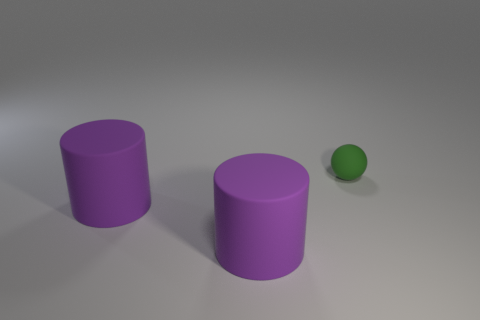How many things are matte objects that are on the left side of the small object or rubber things in front of the small rubber ball?
Offer a terse response. 2. How many other things are there of the same shape as the small rubber object?
Your answer should be compact. 0. What number of other things are the same size as the green matte ball?
Give a very brief answer. 0. Are there more green rubber things than red matte cylinders?
Provide a short and direct response. Yes. How many big things are there?
Ensure brevity in your answer.  2. Are there any other big objects that have the same material as the green thing?
Your answer should be compact. Yes. What material is the green thing?
Your answer should be compact. Rubber. Is the number of green spheres to the left of the sphere less than the number of things?
Make the answer very short. Yes. How many other purple matte objects are the same shape as the tiny thing?
Provide a succinct answer. 0. How many metallic things are green objects or tiny cyan cylinders?
Your answer should be compact. 0. 